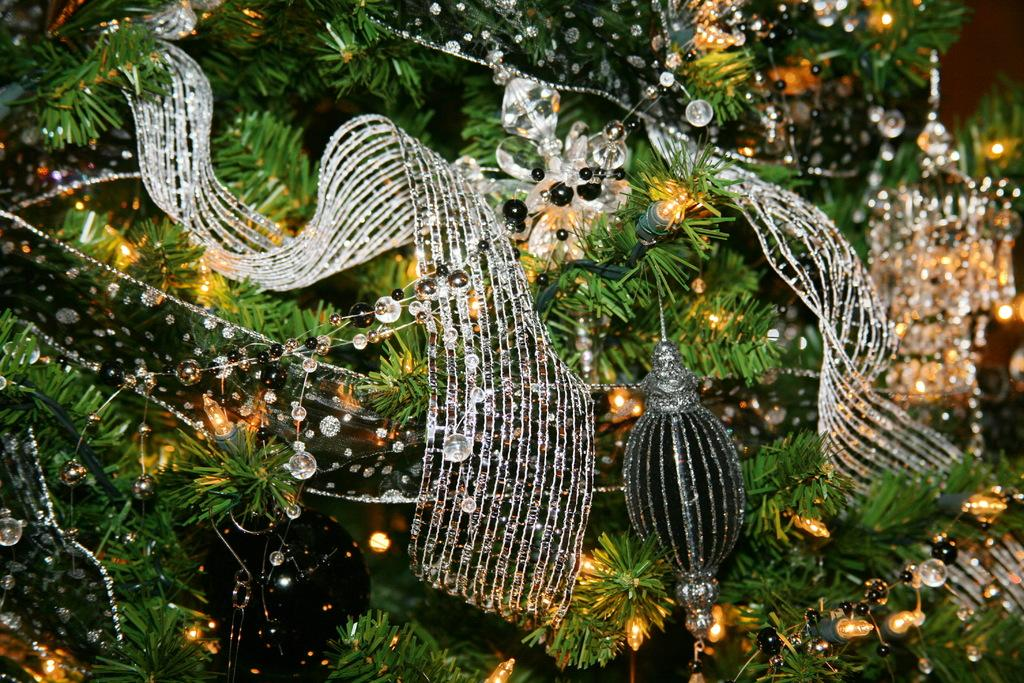What type of tree is featured in the image? There is a Christmas tree in the image. What color is the Christmas tree? The Christmas tree is green. What else can be seen in the image besides the tree? There are decorative items and lights visible in the image. What type of box is located under the Christmas tree in the image? There is no box present under the Christmas tree in the image. 